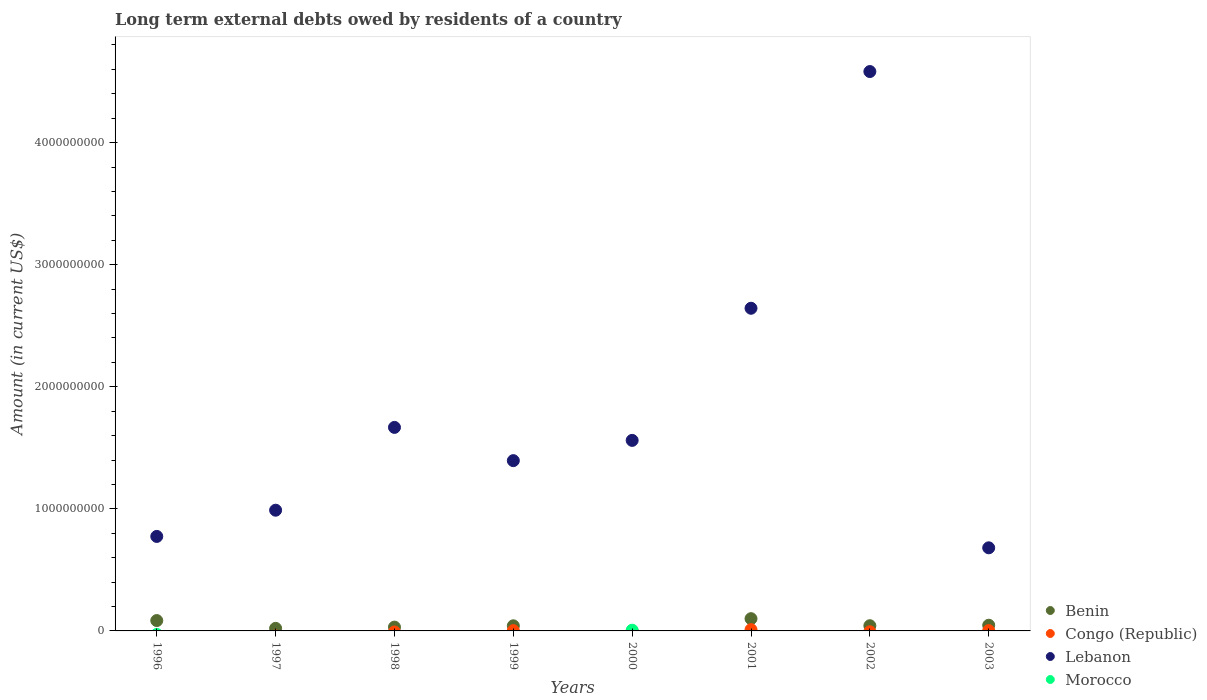How many different coloured dotlines are there?
Your answer should be very brief. 4. Is the number of dotlines equal to the number of legend labels?
Offer a very short reply. No. What is the amount of long-term external debts owed by residents in Lebanon in 2000?
Give a very brief answer. 1.56e+09. Across all years, what is the maximum amount of long-term external debts owed by residents in Benin?
Make the answer very short. 1.00e+08. Across all years, what is the minimum amount of long-term external debts owed by residents in Morocco?
Give a very brief answer. 0. In which year was the amount of long-term external debts owed by residents in Benin maximum?
Offer a very short reply. 2001. What is the total amount of long-term external debts owed by residents in Congo (Republic) in the graph?
Give a very brief answer. 1.55e+07. What is the difference between the amount of long-term external debts owed by residents in Benin in 1999 and that in 2001?
Offer a terse response. -5.86e+07. What is the difference between the amount of long-term external debts owed by residents in Lebanon in 2001 and the amount of long-term external debts owed by residents in Benin in 2000?
Keep it short and to the point. 2.64e+09. What is the average amount of long-term external debts owed by residents in Benin per year?
Offer a terse response. 4.61e+07. In the year 2000, what is the difference between the amount of long-term external debts owed by residents in Lebanon and amount of long-term external debts owed by residents in Morocco?
Your response must be concise. 1.55e+09. What is the ratio of the amount of long-term external debts owed by residents in Lebanon in 2000 to that in 2002?
Your response must be concise. 0.34. Is the amount of long-term external debts owed by residents in Lebanon in 1999 less than that in 2002?
Your response must be concise. Yes. What is the difference between the highest and the second highest amount of long-term external debts owed by residents in Lebanon?
Keep it short and to the point. 1.94e+09. What is the difference between the highest and the lowest amount of long-term external debts owed by residents in Congo (Republic)?
Offer a very short reply. 1.04e+07. In how many years, is the amount of long-term external debts owed by residents in Benin greater than the average amount of long-term external debts owed by residents in Benin taken over all years?
Offer a terse response. 3. Is the sum of the amount of long-term external debts owed by residents in Lebanon in 1996 and 1998 greater than the maximum amount of long-term external debts owed by residents in Benin across all years?
Make the answer very short. Yes. Does the amount of long-term external debts owed by residents in Morocco monotonically increase over the years?
Your answer should be very brief. No. How many dotlines are there?
Provide a short and direct response. 4. What is the difference between two consecutive major ticks on the Y-axis?
Offer a terse response. 1.00e+09. Are the values on the major ticks of Y-axis written in scientific E-notation?
Offer a very short reply. No. Does the graph contain any zero values?
Your answer should be compact. Yes. Does the graph contain grids?
Offer a terse response. No. Where does the legend appear in the graph?
Ensure brevity in your answer.  Bottom right. How many legend labels are there?
Keep it short and to the point. 4. What is the title of the graph?
Your answer should be compact. Long term external debts owed by residents of a country. What is the label or title of the X-axis?
Your answer should be very brief. Years. What is the Amount (in current US$) in Benin in 1996?
Keep it short and to the point. 8.48e+07. What is the Amount (in current US$) in Lebanon in 1996?
Your answer should be compact. 7.74e+08. What is the Amount (in current US$) in Morocco in 1996?
Give a very brief answer. 0. What is the Amount (in current US$) of Benin in 1997?
Your answer should be very brief. 2.10e+07. What is the Amount (in current US$) in Congo (Republic) in 1997?
Ensure brevity in your answer.  0. What is the Amount (in current US$) of Lebanon in 1997?
Offer a very short reply. 9.89e+08. What is the Amount (in current US$) in Benin in 1998?
Offer a very short reply. 3.11e+07. What is the Amount (in current US$) in Lebanon in 1998?
Give a very brief answer. 1.67e+09. What is the Amount (in current US$) of Morocco in 1998?
Your response must be concise. 0. What is the Amount (in current US$) of Benin in 1999?
Ensure brevity in your answer.  4.18e+07. What is the Amount (in current US$) in Congo (Republic) in 1999?
Your response must be concise. 2.45e+06. What is the Amount (in current US$) of Lebanon in 1999?
Your answer should be compact. 1.39e+09. What is the Amount (in current US$) in Congo (Republic) in 2000?
Make the answer very short. 0. What is the Amount (in current US$) in Lebanon in 2000?
Ensure brevity in your answer.  1.56e+09. What is the Amount (in current US$) of Morocco in 2000?
Keep it short and to the point. 5.96e+06. What is the Amount (in current US$) in Benin in 2001?
Your response must be concise. 1.00e+08. What is the Amount (in current US$) of Congo (Republic) in 2001?
Offer a very short reply. 1.04e+07. What is the Amount (in current US$) of Lebanon in 2001?
Keep it short and to the point. 2.64e+09. What is the Amount (in current US$) of Morocco in 2001?
Your response must be concise. 0. What is the Amount (in current US$) in Benin in 2002?
Give a very brief answer. 4.26e+07. What is the Amount (in current US$) in Congo (Republic) in 2002?
Your answer should be very brief. 0. What is the Amount (in current US$) of Lebanon in 2002?
Your answer should be compact. 4.58e+09. What is the Amount (in current US$) in Morocco in 2002?
Provide a short and direct response. 0. What is the Amount (in current US$) of Benin in 2003?
Provide a succinct answer. 4.66e+07. What is the Amount (in current US$) in Congo (Republic) in 2003?
Make the answer very short. 2.65e+06. What is the Amount (in current US$) of Lebanon in 2003?
Give a very brief answer. 6.81e+08. Across all years, what is the maximum Amount (in current US$) of Benin?
Offer a very short reply. 1.00e+08. Across all years, what is the maximum Amount (in current US$) of Congo (Republic)?
Your response must be concise. 1.04e+07. Across all years, what is the maximum Amount (in current US$) in Lebanon?
Ensure brevity in your answer.  4.58e+09. Across all years, what is the maximum Amount (in current US$) in Morocco?
Your answer should be very brief. 5.96e+06. Across all years, what is the minimum Amount (in current US$) in Congo (Republic)?
Give a very brief answer. 0. Across all years, what is the minimum Amount (in current US$) in Lebanon?
Your response must be concise. 6.81e+08. What is the total Amount (in current US$) in Benin in the graph?
Your response must be concise. 3.68e+08. What is the total Amount (in current US$) in Congo (Republic) in the graph?
Offer a very short reply. 1.55e+07. What is the total Amount (in current US$) of Lebanon in the graph?
Ensure brevity in your answer.  1.43e+1. What is the total Amount (in current US$) of Morocco in the graph?
Make the answer very short. 5.96e+06. What is the difference between the Amount (in current US$) in Benin in 1996 and that in 1997?
Make the answer very short. 6.38e+07. What is the difference between the Amount (in current US$) in Lebanon in 1996 and that in 1997?
Offer a very short reply. -2.15e+08. What is the difference between the Amount (in current US$) in Benin in 1996 and that in 1998?
Your answer should be very brief. 5.37e+07. What is the difference between the Amount (in current US$) of Lebanon in 1996 and that in 1998?
Offer a terse response. -8.93e+08. What is the difference between the Amount (in current US$) of Benin in 1996 and that in 1999?
Give a very brief answer. 4.30e+07. What is the difference between the Amount (in current US$) of Lebanon in 1996 and that in 1999?
Give a very brief answer. -6.21e+08. What is the difference between the Amount (in current US$) in Lebanon in 1996 and that in 2000?
Offer a very short reply. -7.87e+08. What is the difference between the Amount (in current US$) in Benin in 1996 and that in 2001?
Provide a succinct answer. -1.55e+07. What is the difference between the Amount (in current US$) in Lebanon in 1996 and that in 2001?
Ensure brevity in your answer.  -1.87e+09. What is the difference between the Amount (in current US$) in Benin in 1996 and that in 2002?
Give a very brief answer. 4.22e+07. What is the difference between the Amount (in current US$) of Lebanon in 1996 and that in 2002?
Your answer should be compact. -3.81e+09. What is the difference between the Amount (in current US$) of Benin in 1996 and that in 2003?
Keep it short and to the point. 3.82e+07. What is the difference between the Amount (in current US$) of Lebanon in 1996 and that in 2003?
Keep it short and to the point. 9.33e+07. What is the difference between the Amount (in current US$) of Benin in 1997 and that in 1998?
Offer a terse response. -1.01e+07. What is the difference between the Amount (in current US$) of Lebanon in 1997 and that in 1998?
Provide a succinct answer. -6.78e+08. What is the difference between the Amount (in current US$) in Benin in 1997 and that in 1999?
Your answer should be very brief. -2.08e+07. What is the difference between the Amount (in current US$) of Lebanon in 1997 and that in 1999?
Provide a succinct answer. -4.06e+08. What is the difference between the Amount (in current US$) in Lebanon in 1997 and that in 2000?
Your answer should be compact. -5.72e+08. What is the difference between the Amount (in current US$) in Benin in 1997 and that in 2001?
Make the answer very short. -7.93e+07. What is the difference between the Amount (in current US$) of Lebanon in 1997 and that in 2001?
Offer a terse response. -1.65e+09. What is the difference between the Amount (in current US$) in Benin in 1997 and that in 2002?
Your answer should be compact. -2.16e+07. What is the difference between the Amount (in current US$) of Lebanon in 1997 and that in 2002?
Keep it short and to the point. -3.59e+09. What is the difference between the Amount (in current US$) of Benin in 1997 and that in 2003?
Ensure brevity in your answer.  -2.56e+07. What is the difference between the Amount (in current US$) of Lebanon in 1997 and that in 2003?
Offer a terse response. 3.08e+08. What is the difference between the Amount (in current US$) of Benin in 1998 and that in 1999?
Offer a very short reply. -1.07e+07. What is the difference between the Amount (in current US$) of Lebanon in 1998 and that in 1999?
Your answer should be compact. 2.72e+08. What is the difference between the Amount (in current US$) of Lebanon in 1998 and that in 2000?
Make the answer very short. 1.06e+08. What is the difference between the Amount (in current US$) in Benin in 1998 and that in 2001?
Offer a very short reply. -6.92e+07. What is the difference between the Amount (in current US$) in Lebanon in 1998 and that in 2001?
Provide a succinct answer. -9.76e+08. What is the difference between the Amount (in current US$) in Benin in 1998 and that in 2002?
Your response must be concise. -1.15e+07. What is the difference between the Amount (in current US$) in Lebanon in 1998 and that in 2002?
Make the answer very short. -2.92e+09. What is the difference between the Amount (in current US$) in Benin in 1998 and that in 2003?
Offer a very short reply. -1.55e+07. What is the difference between the Amount (in current US$) of Lebanon in 1998 and that in 2003?
Your answer should be very brief. 9.86e+08. What is the difference between the Amount (in current US$) in Lebanon in 1999 and that in 2000?
Keep it short and to the point. -1.66e+08. What is the difference between the Amount (in current US$) in Benin in 1999 and that in 2001?
Ensure brevity in your answer.  -5.86e+07. What is the difference between the Amount (in current US$) in Congo (Republic) in 1999 and that in 2001?
Your response must be concise. -7.96e+06. What is the difference between the Amount (in current US$) in Lebanon in 1999 and that in 2001?
Your answer should be very brief. -1.25e+09. What is the difference between the Amount (in current US$) of Benin in 1999 and that in 2002?
Ensure brevity in your answer.  -8.07e+05. What is the difference between the Amount (in current US$) in Lebanon in 1999 and that in 2002?
Provide a short and direct response. -3.19e+09. What is the difference between the Amount (in current US$) in Benin in 1999 and that in 2003?
Provide a short and direct response. -4.83e+06. What is the difference between the Amount (in current US$) in Congo (Republic) in 1999 and that in 2003?
Your answer should be compact. -2.02e+05. What is the difference between the Amount (in current US$) in Lebanon in 1999 and that in 2003?
Provide a succinct answer. 7.14e+08. What is the difference between the Amount (in current US$) of Lebanon in 2000 and that in 2001?
Provide a succinct answer. -1.08e+09. What is the difference between the Amount (in current US$) of Lebanon in 2000 and that in 2002?
Give a very brief answer. -3.02e+09. What is the difference between the Amount (in current US$) in Lebanon in 2000 and that in 2003?
Provide a succinct answer. 8.80e+08. What is the difference between the Amount (in current US$) of Benin in 2001 and that in 2002?
Keep it short and to the point. 5.77e+07. What is the difference between the Amount (in current US$) in Lebanon in 2001 and that in 2002?
Give a very brief answer. -1.94e+09. What is the difference between the Amount (in current US$) in Benin in 2001 and that in 2003?
Provide a succinct answer. 5.37e+07. What is the difference between the Amount (in current US$) in Congo (Republic) in 2001 and that in 2003?
Ensure brevity in your answer.  7.76e+06. What is the difference between the Amount (in current US$) in Lebanon in 2001 and that in 2003?
Offer a terse response. 1.96e+09. What is the difference between the Amount (in current US$) of Benin in 2002 and that in 2003?
Offer a very short reply. -4.02e+06. What is the difference between the Amount (in current US$) of Lebanon in 2002 and that in 2003?
Make the answer very short. 3.90e+09. What is the difference between the Amount (in current US$) in Benin in 1996 and the Amount (in current US$) in Lebanon in 1997?
Your answer should be very brief. -9.04e+08. What is the difference between the Amount (in current US$) in Benin in 1996 and the Amount (in current US$) in Lebanon in 1998?
Your answer should be very brief. -1.58e+09. What is the difference between the Amount (in current US$) of Benin in 1996 and the Amount (in current US$) of Congo (Republic) in 1999?
Keep it short and to the point. 8.24e+07. What is the difference between the Amount (in current US$) in Benin in 1996 and the Amount (in current US$) in Lebanon in 1999?
Your answer should be very brief. -1.31e+09. What is the difference between the Amount (in current US$) of Benin in 1996 and the Amount (in current US$) of Lebanon in 2000?
Your response must be concise. -1.48e+09. What is the difference between the Amount (in current US$) of Benin in 1996 and the Amount (in current US$) of Morocco in 2000?
Your answer should be compact. 7.89e+07. What is the difference between the Amount (in current US$) in Lebanon in 1996 and the Amount (in current US$) in Morocco in 2000?
Keep it short and to the point. 7.68e+08. What is the difference between the Amount (in current US$) in Benin in 1996 and the Amount (in current US$) in Congo (Republic) in 2001?
Ensure brevity in your answer.  7.44e+07. What is the difference between the Amount (in current US$) of Benin in 1996 and the Amount (in current US$) of Lebanon in 2001?
Offer a terse response. -2.56e+09. What is the difference between the Amount (in current US$) in Benin in 1996 and the Amount (in current US$) in Lebanon in 2002?
Make the answer very short. -4.50e+09. What is the difference between the Amount (in current US$) in Benin in 1996 and the Amount (in current US$) in Congo (Republic) in 2003?
Provide a succinct answer. 8.22e+07. What is the difference between the Amount (in current US$) of Benin in 1996 and the Amount (in current US$) of Lebanon in 2003?
Your answer should be very brief. -5.96e+08. What is the difference between the Amount (in current US$) in Benin in 1997 and the Amount (in current US$) in Lebanon in 1998?
Provide a short and direct response. -1.65e+09. What is the difference between the Amount (in current US$) of Benin in 1997 and the Amount (in current US$) of Congo (Republic) in 1999?
Offer a very short reply. 1.86e+07. What is the difference between the Amount (in current US$) of Benin in 1997 and the Amount (in current US$) of Lebanon in 1999?
Make the answer very short. -1.37e+09. What is the difference between the Amount (in current US$) of Benin in 1997 and the Amount (in current US$) of Lebanon in 2000?
Provide a short and direct response. -1.54e+09. What is the difference between the Amount (in current US$) of Benin in 1997 and the Amount (in current US$) of Morocco in 2000?
Give a very brief answer. 1.51e+07. What is the difference between the Amount (in current US$) in Lebanon in 1997 and the Amount (in current US$) in Morocco in 2000?
Give a very brief answer. 9.83e+08. What is the difference between the Amount (in current US$) in Benin in 1997 and the Amount (in current US$) in Congo (Republic) in 2001?
Provide a short and direct response. 1.06e+07. What is the difference between the Amount (in current US$) in Benin in 1997 and the Amount (in current US$) in Lebanon in 2001?
Provide a short and direct response. -2.62e+09. What is the difference between the Amount (in current US$) in Benin in 1997 and the Amount (in current US$) in Lebanon in 2002?
Make the answer very short. -4.56e+09. What is the difference between the Amount (in current US$) of Benin in 1997 and the Amount (in current US$) of Congo (Republic) in 2003?
Keep it short and to the point. 1.84e+07. What is the difference between the Amount (in current US$) of Benin in 1997 and the Amount (in current US$) of Lebanon in 2003?
Ensure brevity in your answer.  -6.60e+08. What is the difference between the Amount (in current US$) of Benin in 1998 and the Amount (in current US$) of Congo (Republic) in 1999?
Provide a short and direct response. 2.87e+07. What is the difference between the Amount (in current US$) in Benin in 1998 and the Amount (in current US$) in Lebanon in 1999?
Give a very brief answer. -1.36e+09. What is the difference between the Amount (in current US$) in Benin in 1998 and the Amount (in current US$) in Lebanon in 2000?
Provide a short and direct response. -1.53e+09. What is the difference between the Amount (in current US$) of Benin in 1998 and the Amount (in current US$) of Morocco in 2000?
Your answer should be compact. 2.52e+07. What is the difference between the Amount (in current US$) of Lebanon in 1998 and the Amount (in current US$) of Morocco in 2000?
Your response must be concise. 1.66e+09. What is the difference between the Amount (in current US$) of Benin in 1998 and the Amount (in current US$) of Congo (Republic) in 2001?
Offer a very short reply. 2.07e+07. What is the difference between the Amount (in current US$) of Benin in 1998 and the Amount (in current US$) of Lebanon in 2001?
Provide a succinct answer. -2.61e+09. What is the difference between the Amount (in current US$) of Benin in 1998 and the Amount (in current US$) of Lebanon in 2002?
Offer a terse response. -4.55e+09. What is the difference between the Amount (in current US$) in Benin in 1998 and the Amount (in current US$) in Congo (Republic) in 2003?
Keep it short and to the point. 2.85e+07. What is the difference between the Amount (in current US$) of Benin in 1998 and the Amount (in current US$) of Lebanon in 2003?
Provide a succinct answer. -6.50e+08. What is the difference between the Amount (in current US$) in Benin in 1999 and the Amount (in current US$) in Lebanon in 2000?
Your answer should be very brief. -1.52e+09. What is the difference between the Amount (in current US$) of Benin in 1999 and the Amount (in current US$) of Morocco in 2000?
Your answer should be compact. 3.58e+07. What is the difference between the Amount (in current US$) of Congo (Republic) in 1999 and the Amount (in current US$) of Lebanon in 2000?
Give a very brief answer. -1.56e+09. What is the difference between the Amount (in current US$) in Congo (Republic) in 1999 and the Amount (in current US$) in Morocco in 2000?
Offer a very short reply. -3.51e+06. What is the difference between the Amount (in current US$) in Lebanon in 1999 and the Amount (in current US$) in Morocco in 2000?
Ensure brevity in your answer.  1.39e+09. What is the difference between the Amount (in current US$) in Benin in 1999 and the Amount (in current US$) in Congo (Republic) in 2001?
Give a very brief answer. 3.14e+07. What is the difference between the Amount (in current US$) of Benin in 1999 and the Amount (in current US$) of Lebanon in 2001?
Your response must be concise. -2.60e+09. What is the difference between the Amount (in current US$) in Congo (Republic) in 1999 and the Amount (in current US$) in Lebanon in 2001?
Offer a terse response. -2.64e+09. What is the difference between the Amount (in current US$) of Benin in 1999 and the Amount (in current US$) of Lebanon in 2002?
Your answer should be very brief. -4.54e+09. What is the difference between the Amount (in current US$) of Congo (Republic) in 1999 and the Amount (in current US$) of Lebanon in 2002?
Ensure brevity in your answer.  -4.58e+09. What is the difference between the Amount (in current US$) in Benin in 1999 and the Amount (in current US$) in Congo (Republic) in 2003?
Offer a very short reply. 3.92e+07. What is the difference between the Amount (in current US$) in Benin in 1999 and the Amount (in current US$) in Lebanon in 2003?
Give a very brief answer. -6.39e+08. What is the difference between the Amount (in current US$) in Congo (Republic) in 1999 and the Amount (in current US$) in Lebanon in 2003?
Your response must be concise. -6.78e+08. What is the difference between the Amount (in current US$) in Benin in 2001 and the Amount (in current US$) in Lebanon in 2002?
Provide a succinct answer. -4.48e+09. What is the difference between the Amount (in current US$) in Congo (Republic) in 2001 and the Amount (in current US$) in Lebanon in 2002?
Ensure brevity in your answer.  -4.57e+09. What is the difference between the Amount (in current US$) of Benin in 2001 and the Amount (in current US$) of Congo (Republic) in 2003?
Ensure brevity in your answer.  9.77e+07. What is the difference between the Amount (in current US$) in Benin in 2001 and the Amount (in current US$) in Lebanon in 2003?
Give a very brief answer. -5.80e+08. What is the difference between the Amount (in current US$) in Congo (Republic) in 2001 and the Amount (in current US$) in Lebanon in 2003?
Make the answer very short. -6.70e+08. What is the difference between the Amount (in current US$) in Benin in 2002 and the Amount (in current US$) in Congo (Republic) in 2003?
Your response must be concise. 4.00e+07. What is the difference between the Amount (in current US$) in Benin in 2002 and the Amount (in current US$) in Lebanon in 2003?
Your answer should be compact. -6.38e+08. What is the average Amount (in current US$) in Benin per year?
Ensure brevity in your answer.  4.61e+07. What is the average Amount (in current US$) in Congo (Republic) per year?
Make the answer very short. 1.94e+06. What is the average Amount (in current US$) of Lebanon per year?
Make the answer very short. 1.79e+09. What is the average Amount (in current US$) of Morocco per year?
Offer a terse response. 7.45e+05. In the year 1996, what is the difference between the Amount (in current US$) of Benin and Amount (in current US$) of Lebanon?
Make the answer very short. -6.89e+08. In the year 1997, what is the difference between the Amount (in current US$) in Benin and Amount (in current US$) in Lebanon?
Offer a very short reply. -9.68e+08. In the year 1998, what is the difference between the Amount (in current US$) of Benin and Amount (in current US$) of Lebanon?
Make the answer very short. -1.64e+09. In the year 1999, what is the difference between the Amount (in current US$) in Benin and Amount (in current US$) in Congo (Republic)?
Provide a short and direct response. 3.94e+07. In the year 1999, what is the difference between the Amount (in current US$) in Benin and Amount (in current US$) in Lebanon?
Provide a succinct answer. -1.35e+09. In the year 1999, what is the difference between the Amount (in current US$) of Congo (Republic) and Amount (in current US$) of Lebanon?
Offer a terse response. -1.39e+09. In the year 2000, what is the difference between the Amount (in current US$) of Lebanon and Amount (in current US$) of Morocco?
Give a very brief answer. 1.55e+09. In the year 2001, what is the difference between the Amount (in current US$) of Benin and Amount (in current US$) of Congo (Republic)?
Provide a short and direct response. 8.99e+07. In the year 2001, what is the difference between the Amount (in current US$) in Benin and Amount (in current US$) in Lebanon?
Offer a terse response. -2.54e+09. In the year 2001, what is the difference between the Amount (in current US$) of Congo (Republic) and Amount (in current US$) of Lebanon?
Your answer should be compact. -2.63e+09. In the year 2002, what is the difference between the Amount (in current US$) in Benin and Amount (in current US$) in Lebanon?
Ensure brevity in your answer.  -4.54e+09. In the year 2003, what is the difference between the Amount (in current US$) in Benin and Amount (in current US$) in Congo (Republic)?
Offer a very short reply. 4.40e+07. In the year 2003, what is the difference between the Amount (in current US$) in Benin and Amount (in current US$) in Lebanon?
Provide a short and direct response. -6.34e+08. In the year 2003, what is the difference between the Amount (in current US$) of Congo (Republic) and Amount (in current US$) of Lebanon?
Your response must be concise. -6.78e+08. What is the ratio of the Amount (in current US$) of Benin in 1996 to that in 1997?
Offer a terse response. 4.03. What is the ratio of the Amount (in current US$) in Lebanon in 1996 to that in 1997?
Ensure brevity in your answer.  0.78. What is the ratio of the Amount (in current US$) in Benin in 1996 to that in 1998?
Your answer should be very brief. 2.72. What is the ratio of the Amount (in current US$) of Lebanon in 1996 to that in 1998?
Your answer should be very brief. 0.46. What is the ratio of the Amount (in current US$) in Benin in 1996 to that in 1999?
Provide a succinct answer. 2.03. What is the ratio of the Amount (in current US$) in Lebanon in 1996 to that in 1999?
Keep it short and to the point. 0.56. What is the ratio of the Amount (in current US$) of Lebanon in 1996 to that in 2000?
Offer a terse response. 0.5. What is the ratio of the Amount (in current US$) in Benin in 1996 to that in 2001?
Give a very brief answer. 0.85. What is the ratio of the Amount (in current US$) of Lebanon in 1996 to that in 2001?
Your answer should be very brief. 0.29. What is the ratio of the Amount (in current US$) in Benin in 1996 to that in 2002?
Ensure brevity in your answer.  1.99. What is the ratio of the Amount (in current US$) in Lebanon in 1996 to that in 2002?
Provide a succinct answer. 0.17. What is the ratio of the Amount (in current US$) of Benin in 1996 to that in 2003?
Keep it short and to the point. 1.82. What is the ratio of the Amount (in current US$) in Lebanon in 1996 to that in 2003?
Ensure brevity in your answer.  1.14. What is the ratio of the Amount (in current US$) of Benin in 1997 to that in 1998?
Your response must be concise. 0.68. What is the ratio of the Amount (in current US$) in Lebanon in 1997 to that in 1998?
Provide a succinct answer. 0.59. What is the ratio of the Amount (in current US$) of Benin in 1997 to that in 1999?
Offer a very short reply. 0.5. What is the ratio of the Amount (in current US$) in Lebanon in 1997 to that in 1999?
Your answer should be very brief. 0.71. What is the ratio of the Amount (in current US$) of Lebanon in 1997 to that in 2000?
Your response must be concise. 0.63. What is the ratio of the Amount (in current US$) of Benin in 1997 to that in 2001?
Provide a succinct answer. 0.21. What is the ratio of the Amount (in current US$) of Lebanon in 1997 to that in 2001?
Provide a short and direct response. 0.37. What is the ratio of the Amount (in current US$) of Benin in 1997 to that in 2002?
Your answer should be compact. 0.49. What is the ratio of the Amount (in current US$) in Lebanon in 1997 to that in 2002?
Your response must be concise. 0.22. What is the ratio of the Amount (in current US$) in Benin in 1997 to that in 2003?
Your answer should be compact. 0.45. What is the ratio of the Amount (in current US$) in Lebanon in 1997 to that in 2003?
Give a very brief answer. 1.45. What is the ratio of the Amount (in current US$) of Benin in 1998 to that in 1999?
Your answer should be compact. 0.74. What is the ratio of the Amount (in current US$) in Lebanon in 1998 to that in 1999?
Your answer should be compact. 1.2. What is the ratio of the Amount (in current US$) in Lebanon in 1998 to that in 2000?
Ensure brevity in your answer.  1.07. What is the ratio of the Amount (in current US$) in Benin in 1998 to that in 2001?
Keep it short and to the point. 0.31. What is the ratio of the Amount (in current US$) of Lebanon in 1998 to that in 2001?
Your answer should be compact. 0.63. What is the ratio of the Amount (in current US$) of Benin in 1998 to that in 2002?
Your answer should be compact. 0.73. What is the ratio of the Amount (in current US$) of Lebanon in 1998 to that in 2002?
Your response must be concise. 0.36. What is the ratio of the Amount (in current US$) in Benin in 1998 to that in 2003?
Offer a very short reply. 0.67. What is the ratio of the Amount (in current US$) of Lebanon in 1998 to that in 2003?
Ensure brevity in your answer.  2.45. What is the ratio of the Amount (in current US$) of Lebanon in 1999 to that in 2000?
Your answer should be compact. 0.89. What is the ratio of the Amount (in current US$) of Benin in 1999 to that in 2001?
Offer a very short reply. 0.42. What is the ratio of the Amount (in current US$) of Congo (Republic) in 1999 to that in 2001?
Give a very brief answer. 0.24. What is the ratio of the Amount (in current US$) of Lebanon in 1999 to that in 2001?
Provide a succinct answer. 0.53. What is the ratio of the Amount (in current US$) in Benin in 1999 to that in 2002?
Offer a terse response. 0.98. What is the ratio of the Amount (in current US$) of Lebanon in 1999 to that in 2002?
Ensure brevity in your answer.  0.3. What is the ratio of the Amount (in current US$) of Benin in 1999 to that in 2003?
Your response must be concise. 0.9. What is the ratio of the Amount (in current US$) in Congo (Republic) in 1999 to that in 2003?
Give a very brief answer. 0.92. What is the ratio of the Amount (in current US$) of Lebanon in 1999 to that in 2003?
Your response must be concise. 2.05. What is the ratio of the Amount (in current US$) in Lebanon in 2000 to that in 2001?
Your answer should be very brief. 0.59. What is the ratio of the Amount (in current US$) of Lebanon in 2000 to that in 2002?
Your answer should be compact. 0.34. What is the ratio of the Amount (in current US$) of Lebanon in 2000 to that in 2003?
Make the answer very short. 2.29. What is the ratio of the Amount (in current US$) of Benin in 2001 to that in 2002?
Your response must be concise. 2.36. What is the ratio of the Amount (in current US$) of Lebanon in 2001 to that in 2002?
Offer a terse response. 0.58. What is the ratio of the Amount (in current US$) in Benin in 2001 to that in 2003?
Keep it short and to the point. 2.15. What is the ratio of the Amount (in current US$) in Congo (Republic) in 2001 to that in 2003?
Make the answer very short. 3.92. What is the ratio of the Amount (in current US$) of Lebanon in 2001 to that in 2003?
Provide a succinct answer. 3.88. What is the ratio of the Amount (in current US$) of Benin in 2002 to that in 2003?
Make the answer very short. 0.91. What is the ratio of the Amount (in current US$) of Lebanon in 2002 to that in 2003?
Give a very brief answer. 6.73. What is the difference between the highest and the second highest Amount (in current US$) in Benin?
Your answer should be very brief. 1.55e+07. What is the difference between the highest and the second highest Amount (in current US$) in Congo (Republic)?
Offer a terse response. 7.76e+06. What is the difference between the highest and the second highest Amount (in current US$) in Lebanon?
Offer a terse response. 1.94e+09. What is the difference between the highest and the lowest Amount (in current US$) in Benin?
Give a very brief answer. 1.00e+08. What is the difference between the highest and the lowest Amount (in current US$) in Congo (Republic)?
Make the answer very short. 1.04e+07. What is the difference between the highest and the lowest Amount (in current US$) of Lebanon?
Your response must be concise. 3.90e+09. What is the difference between the highest and the lowest Amount (in current US$) of Morocco?
Your answer should be very brief. 5.96e+06. 